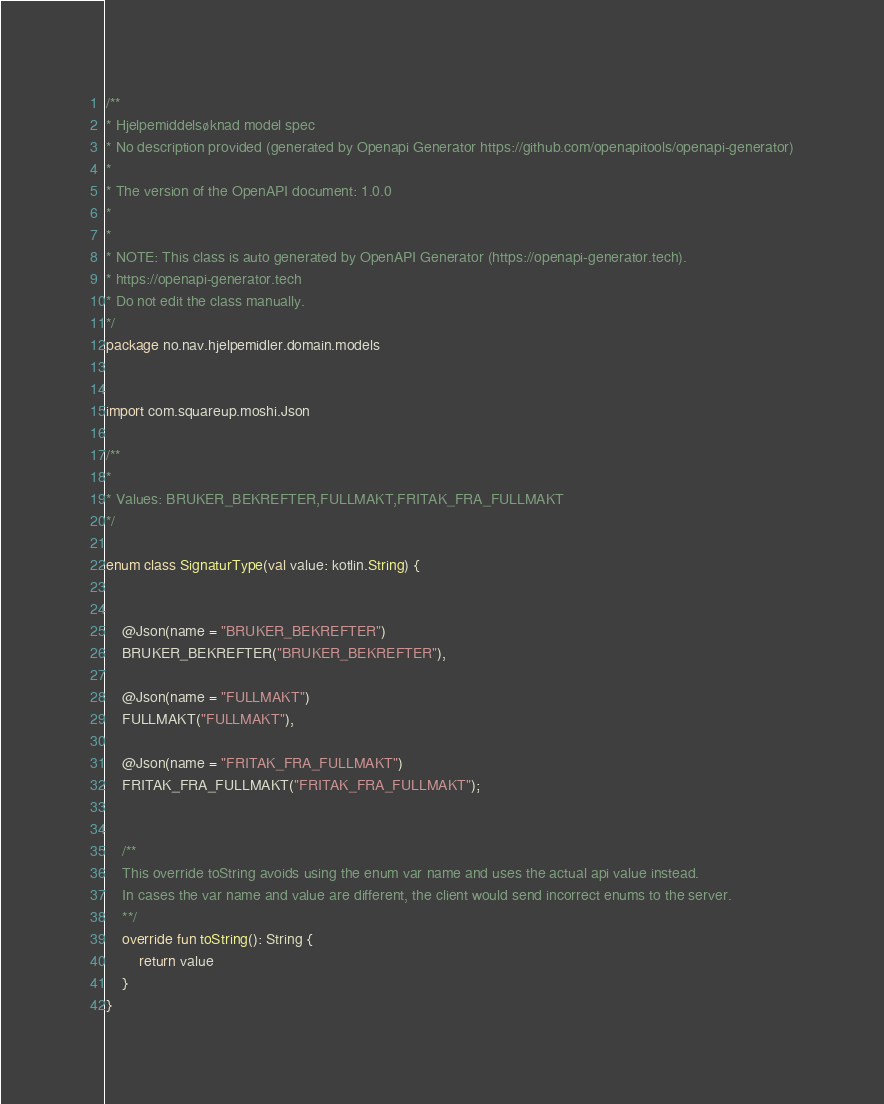Convert code to text. <code><loc_0><loc_0><loc_500><loc_500><_Kotlin_>/**
* Hjelpemiddelsøknad model spec
* No description provided (generated by Openapi Generator https://github.com/openapitools/openapi-generator)
*
* The version of the OpenAPI document: 1.0.0
* 
*
* NOTE: This class is auto generated by OpenAPI Generator (https://openapi-generator.tech).
* https://openapi-generator.tech
* Do not edit the class manually.
*/
package no.nav.hjelpemidler.domain.models


import com.squareup.moshi.Json

/**
* 
* Values: BRUKER_BEKREFTER,FULLMAKT,FRITAK_FRA_FULLMAKT
*/

enum class SignaturType(val value: kotlin.String) {


    @Json(name = "BRUKER_BEKREFTER")
    BRUKER_BEKREFTER("BRUKER_BEKREFTER"),

    @Json(name = "FULLMAKT")
    FULLMAKT("FULLMAKT"),

    @Json(name = "FRITAK_FRA_FULLMAKT")
    FRITAK_FRA_FULLMAKT("FRITAK_FRA_FULLMAKT");


    /**
    This override toString avoids using the enum var name and uses the actual api value instead.
    In cases the var name and value are different, the client would send incorrect enums to the server.
    **/
    override fun toString(): String {
        return value
    }
}

</code> 